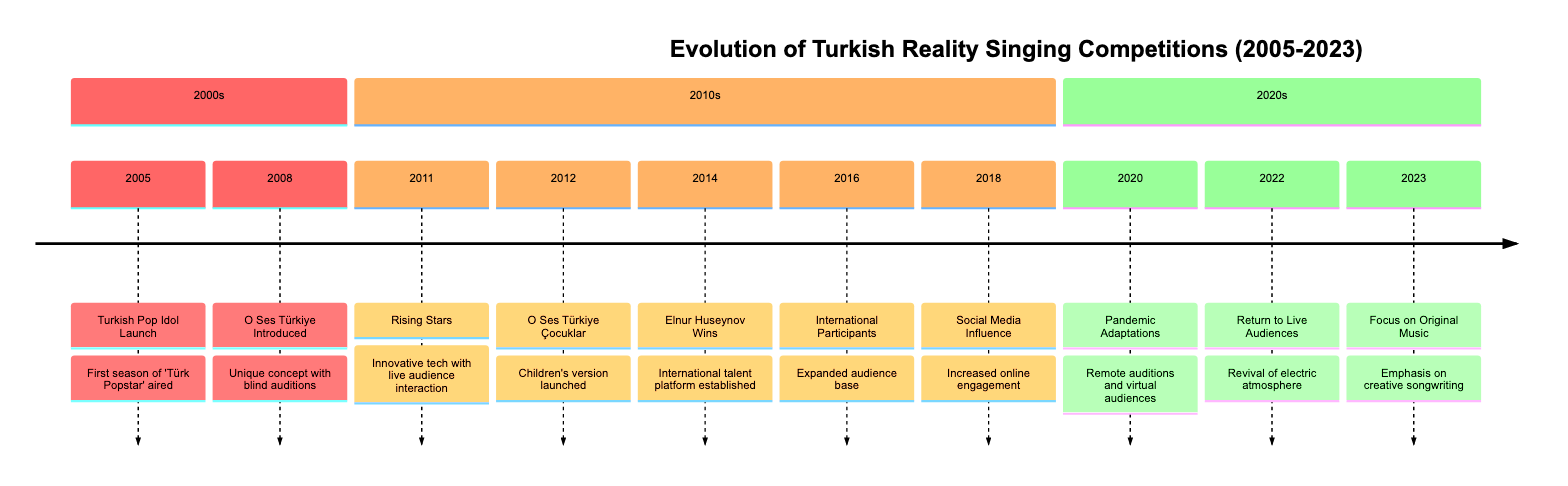What year did 'Turkish Pop Idol' launch? The timeline directly states that 'Turkish Pop Idol' launched in the year 2005.
Answer: 2005 What concept was introduced in 2008? In 2008, the timeline mentions the introduction of 'O Ses Türkiye' which offered a unique concept with blind auditions.
Answer: O Ses Türkiye Which competition emphasized original compositions in 2023? The timeline indicates that in 2023, 'O Ses Türkiye' put a focus on original music compositions by participants.
Answer: O Ses Türkiye How many events are listed in the 2010s section of the timeline? Counting the events listed in the 2010s section reveals a total of six significant events from 2011 to 2018.
Answer: 6 What adaptation occurred due to the COVID-19 pandemic? The event in 2020 highlighted that reality singing competitions like 'O Ses Türkiye' adapted by incorporating remote auditions.
Answer: Remote auditions Which year saw a children's version of 'O Ses Türkiye' launched? Per the timeline, the children's version called 'O Ses Türkiye Çocuklar' was launched in 2012.
Answer: 2012 What major influence began in 2018 affecting audience engagement? The timeline specifies that in 2018, social media platforms began to significantly influence audience engagement and participants' promotion.
Answer: Social Media Influence Which contestant's win in 2014 cemented 'O Ses Türkiye' as a platform for international talent? According to the timeline, Elnur Huseynov's victory in 2014 established 'O Ses Türkiye' as a platform for international talent.
Answer: Elnur Huseynov In which year did 'O Ses Türkiye' start welcoming participants from neighboring countries? The timeline reveals that this event occurred in 2016 when 'O Ses Türkiye' started welcoming international participants.
Answer: 2016 